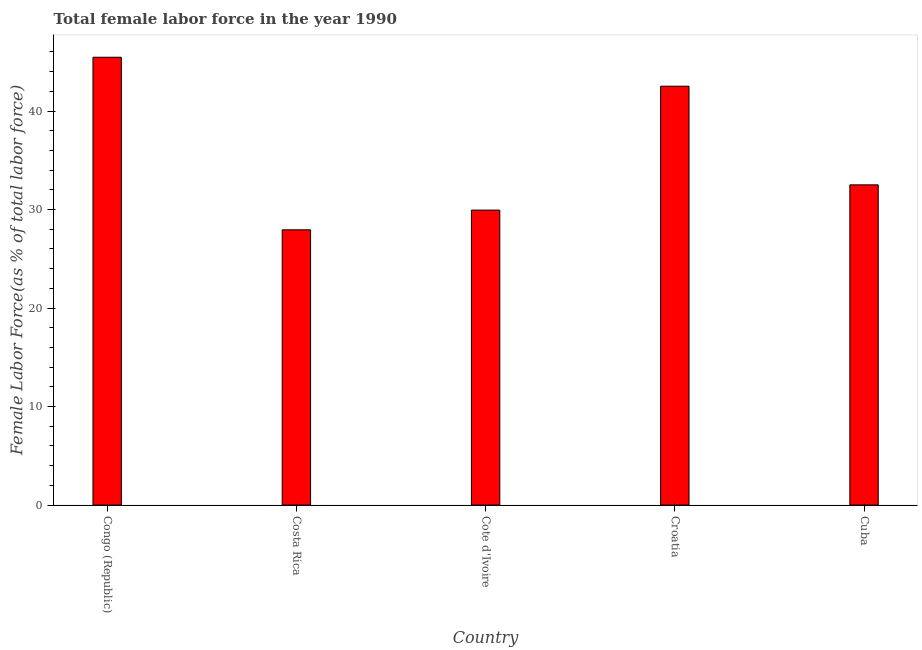Does the graph contain any zero values?
Your answer should be compact. No. Does the graph contain grids?
Give a very brief answer. No. What is the title of the graph?
Offer a very short reply. Total female labor force in the year 1990. What is the label or title of the Y-axis?
Make the answer very short. Female Labor Force(as % of total labor force). What is the total female labor force in Congo (Republic)?
Your answer should be compact. 45.46. Across all countries, what is the maximum total female labor force?
Offer a very short reply. 45.46. Across all countries, what is the minimum total female labor force?
Your response must be concise. 27.94. In which country was the total female labor force maximum?
Keep it short and to the point. Congo (Republic). What is the sum of the total female labor force?
Offer a very short reply. 178.39. What is the difference between the total female labor force in Congo (Republic) and Cuba?
Provide a succinct answer. 12.95. What is the average total female labor force per country?
Provide a succinct answer. 35.68. What is the median total female labor force?
Keep it short and to the point. 32.51. What is the ratio of the total female labor force in Congo (Republic) to that in Cuba?
Your answer should be very brief. 1.4. Is the total female labor force in Costa Rica less than that in Cuba?
Offer a terse response. Yes. Is the difference between the total female labor force in Congo (Republic) and Croatia greater than the difference between any two countries?
Provide a succinct answer. No. What is the difference between the highest and the second highest total female labor force?
Give a very brief answer. 2.94. Is the sum of the total female labor force in Congo (Republic) and Cuba greater than the maximum total female labor force across all countries?
Your answer should be very brief. Yes. What is the difference between the highest and the lowest total female labor force?
Make the answer very short. 17.52. In how many countries, is the total female labor force greater than the average total female labor force taken over all countries?
Your answer should be compact. 2. How many bars are there?
Offer a terse response. 5. Are all the bars in the graph horizontal?
Your answer should be compact. No. What is the Female Labor Force(as % of total labor force) in Congo (Republic)?
Make the answer very short. 45.46. What is the Female Labor Force(as % of total labor force) in Costa Rica?
Your answer should be very brief. 27.94. What is the Female Labor Force(as % of total labor force) in Cote d'Ivoire?
Offer a terse response. 29.95. What is the Female Labor Force(as % of total labor force) of Croatia?
Provide a succinct answer. 42.53. What is the Female Labor Force(as % of total labor force) of Cuba?
Offer a very short reply. 32.51. What is the difference between the Female Labor Force(as % of total labor force) in Congo (Republic) and Costa Rica?
Your answer should be compact. 17.52. What is the difference between the Female Labor Force(as % of total labor force) in Congo (Republic) and Cote d'Ivoire?
Keep it short and to the point. 15.52. What is the difference between the Female Labor Force(as % of total labor force) in Congo (Republic) and Croatia?
Provide a succinct answer. 2.94. What is the difference between the Female Labor Force(as % of total labor force) in Congo (Republic) and Cuba?
Provide a short and direct response. 12.95. What is the difference between the Female Labor Force(as % of total labor force) in Costa Rica and Cote d'Ivoire?
Give a very brief answer. -2. What is the difference between the Female Labor Force(as % of total labor force) in Costa Rica and Croatia?
Offer a very short reply. -14.58. What is the difference between the Female Labor Force(as % of total labor force) in Costa Rica and Cuba?
Provide a short and direct response. -4.57. What is the difference between the Female Labor Force(as % of total labor force) in Cote d'Ivoire and Croatia?
Provide a succinct answer. -12.58. What is the difference between the Female Labor Force(as % of total labor force) in Cote d'Ivoire and Cuba?
Offer a terse response. -2.56. What is the difference between the Female Labor Force(as % of total labor force) in Croatia and Cuba?
Your response must be concise. 10.02. What is the ratio of the Female Labor Force(as % of total labor force) in Congo (Republic) to that in Costa Rica?
Ensure brevity in your answer.  1.63. What is the ratio of the Female Labor Force(as % of total labor force) in Congo (Republic) to that in Cote d'Ivoire?
Your response must be concise. 1.52. What is the ratio of the Female Labor Force(as % of total labor force) in Congo (Republic) to that in Croatia?
Ensure brevity in your answer.  1.07. What is the ratio of the Female Labor Force(as % of total labor force) in Congo (Republic) to that in Cuba?
Make the answer very short. 1.4. What is the ratio of the Female Labor Force(as % of total labor force) in Costa Rica to that in Cote d'Ivoire?
Give a very brief answer. 0.93. What is the ratio of the Female Labor Force(as % of total labor force) in Costa Rica to that in Croatia?
Keep it short and to the point. 0.66. What is the ratio of the Female Labor Force(as % of total labor force) in Costa Rica to that in Cuba?
Your answer should be very brief. 0.86. What is the ratio of the Female Labor Force(as % of total labor force) in Cote d'Ivoire to that in Croatia?
Provide a short and direct response. 0.7. What is the ratio of the Female Labor Force(as % of total labor force) in Cote d'Ivoire to that in Cuba?
Provide a succinct answer. 0.92. What is the ratio of the Female Labor Force(as % of total labor force) in Croatia to that in Cuba?
Make the answer very short. 1.31. 